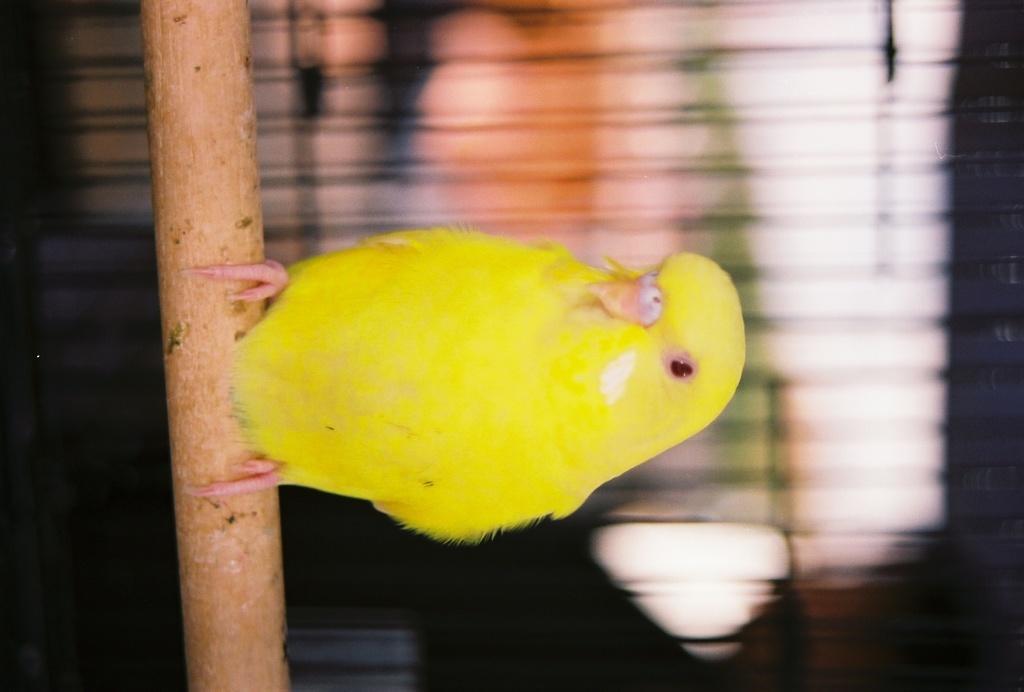Describe this image in one or two sentences. In the image we can see there is a bird standing on the tree log. 